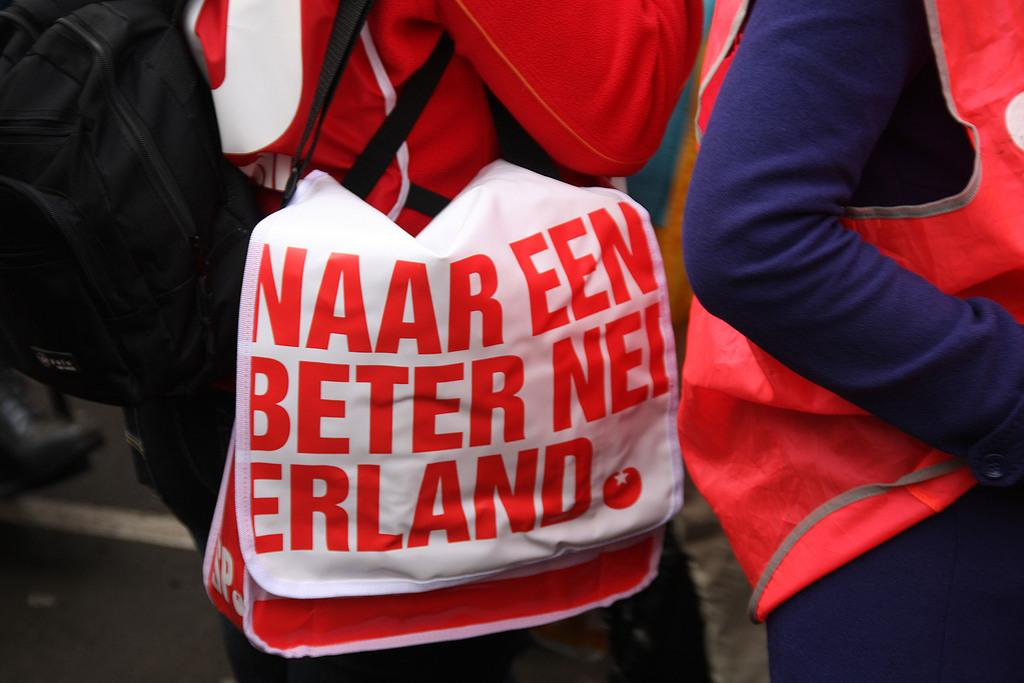<image>
Provide a brief description of the given image. A person with a shoulder bag that says Naar Een Better Nei Erland is walking in a crowd. 